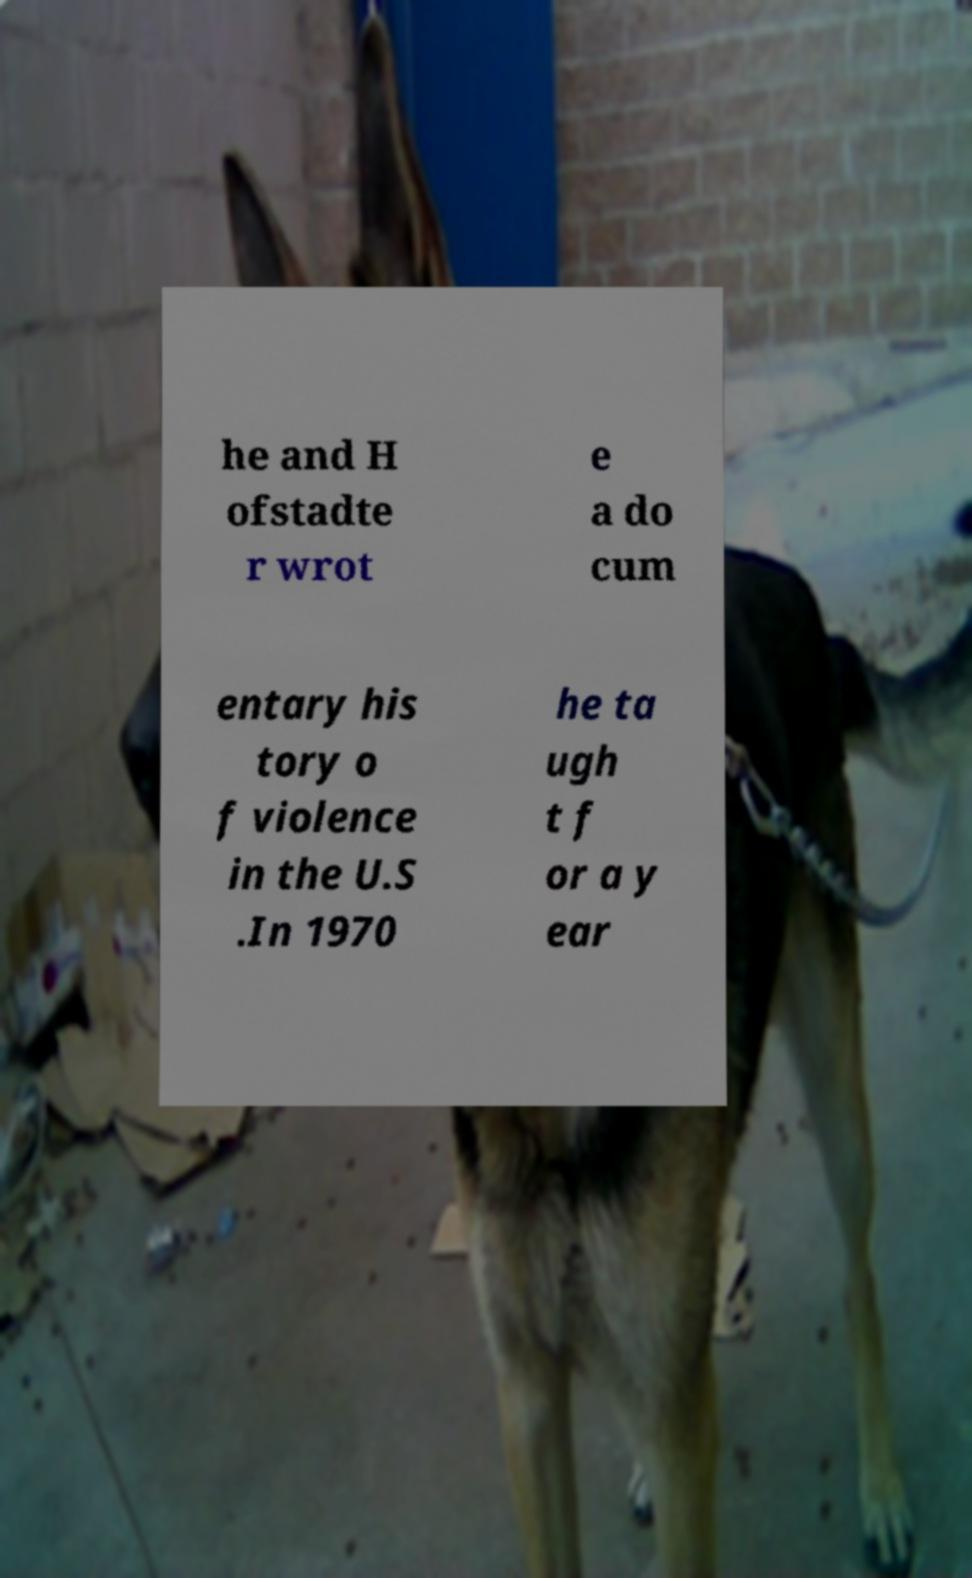I need the written content from this picture converted into text. Can you do that? he and H ofstadte r wrot e a do cum entary his tory o f violence in the U.S .In 1970 he ta ugh t f or a y ear 